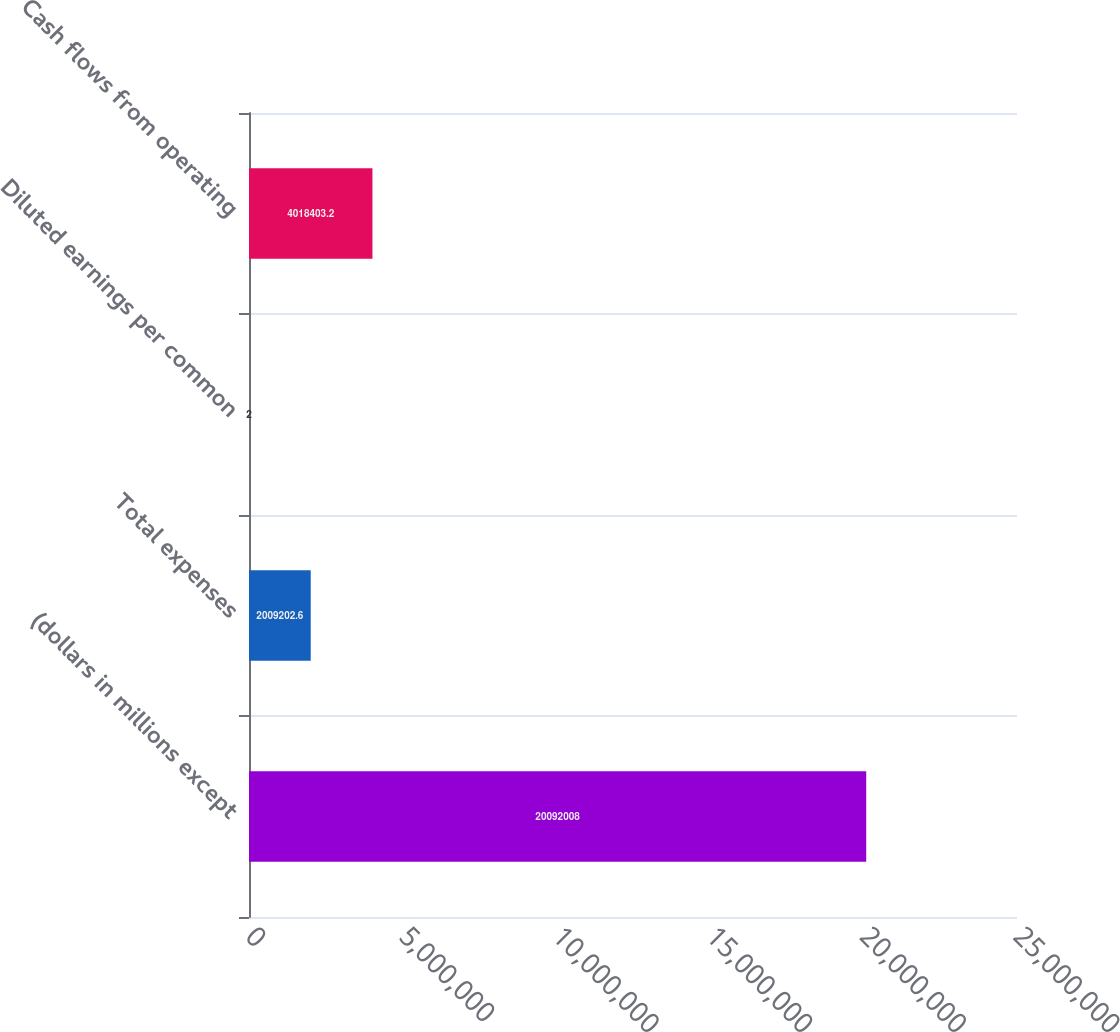<chart> <loc_0><loc_0><loc_500><loc_500><bar_chart><fcel>(dollars in millions except<fcel>Total expenses<fcel>Diluted earnings per common<fcel>Cash flows from operating<nl><fcel>2.0092e+07<fcel>2.0092e+06<fcel>2<fcel>4.0184e+06<nl></chart> 